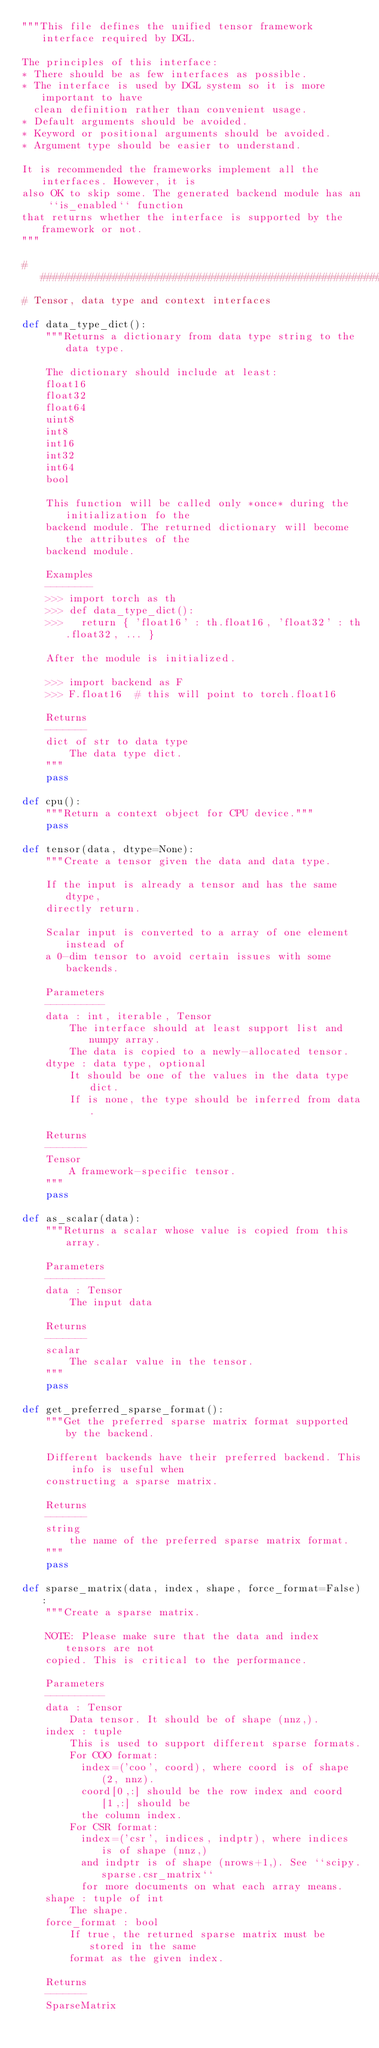Convert code to text. <code><loc_0><loc_0><loc_500><loc_500><_Python_>"""This file defines the unified tensor framework interface required by DGL.

The principles of this interface:
* There should be as few interfaces as possible.
* The interface is used by DGL system so it is more important to have
  clean definition rather than convenient usage.
* Default arguments should be avoided.
* Keyword or positional arguments should be avoided.
* Argument type should be easier to understand.

It is recommended the frameworks implement all the interfaces. However, it is
also OK to skip some. The generated backend module has an ``is_enabled`` function
that returns whether the interface is supported by the framework or not.
"""

###############################################################################
# Tensor, data type and context interfaces

def data_type_dict():
    """Returns a dictionary from data type string to the data type.

    The dictionary should include at least:
    float16
    float32
    float64
    uint8
    int8
    int16
    int32
    int64
    bool

    This function will be called only *once* during the initialization fo the
    backend module. The returned dictionary will become the attributes of the
    backend module.

    Examples
    --------
    >>> import torch as th
    >>> def data_type_dict():
    >>>   return { 'float16' : th.float16, 'float32' : th.float32, ... }

    After the module is initialized.

    >>> import backend as F
    >>> F.float16  # this will point to torch.float16

    Returns
    -------
    dict of str to data type
        The data type dict.
    """
    pass

def cpu():
    """Return a context object for CPU device."""
    pass

def tensor(data, dtype=None):
    """Create a tensor given the data and data type.

    If the input is already a tensor and has the same dtype,
    directly return.

    Scalar input is converted to a array of one element instead of
    a 0-dim tensor to avoid certain issues with some backends.

    Parameters
    ----------
    data : int, iterable, Tensor
        The interface should at least support list and numpy array.
        The data is copied to a newly-allocated tensor.
    dtype : data type, optional
        It should be one of the values in the data type dict.
        If is none, the type should be inferred from data.

    Returns
    -------
    Tensor
        A framework-specific tensor.
    """
    pass

def as_scalar(data):
    """Returns a scalar whose value is copied from this array.

    Parameters
    ----------
    data : Tensor
        The input data

    Returns
    -------
    scalar
        The scalar value in the tensor.
    """
    pass

def get_preferred_sparse_format():
    """Get the preferred sparse matrix format supported by the backend.

    Different backends have their preferred backend. This info is useful when
    constructing a sparse matrix.

    Returns
    -------
    string
        the name of the preferred sparse matrix format.
    """
    pass

def sparse_matrix(data, index, shape, force_format=False):
    """Create a sparse matrix.

    NOTE: Please make sure that the data and index tensors are not
    copied. This is critical to the performance.

    Parameters
    ----------
    data : Tensor
        Data tensor. It should be of shape (nnz,).
    index : tuple
        This is used to support different sparse formats.
        For COO format:
          index=('coo', coord), where coord is of shape (2, nnz).
          coord[0,:] should be the row index and coord[1,:] should be
          the column index.
        For CSR format:
          index=('csr', indices, indptr), where indices is of shape (nnz,)
          and indptr is of shape (nrows+1,). See ``scipy.sparse.csr_matrix``
          for more documents on what each array means.
    shape : tuple of int
        The shape.
    force_format : bool
        If true, the returned sparse matrix must be stored in the same
        format as the given index.

    Returns
    -------
    SparseMatrix</code> 